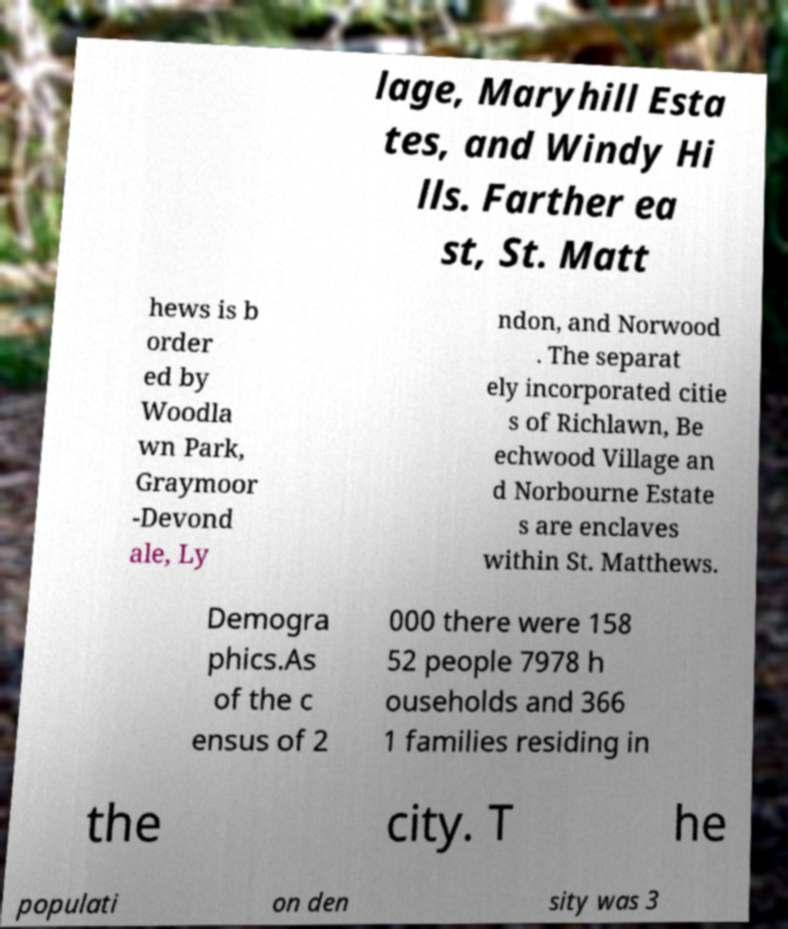For documentation purposes, I need the text within this image transcribed. Could you provide that? lage, Maryhill Esta tes, and Windy Hi lls. Farther ea st, St. Matt hews is b order ed by Woodla wn Park, Graymoor -Devond ale, Ly ndon, and Norwood . The separat ely incorporated citie s of Richlawn, Be echwood Village an d Norbourne Estate s are enclaves within St. Matthews. Demogra phics.As of the c ensus of 2 000 there were 158 52 people 7978 h ouseholds and 366 1 families residing in the city. T he populati on den sity was 3 